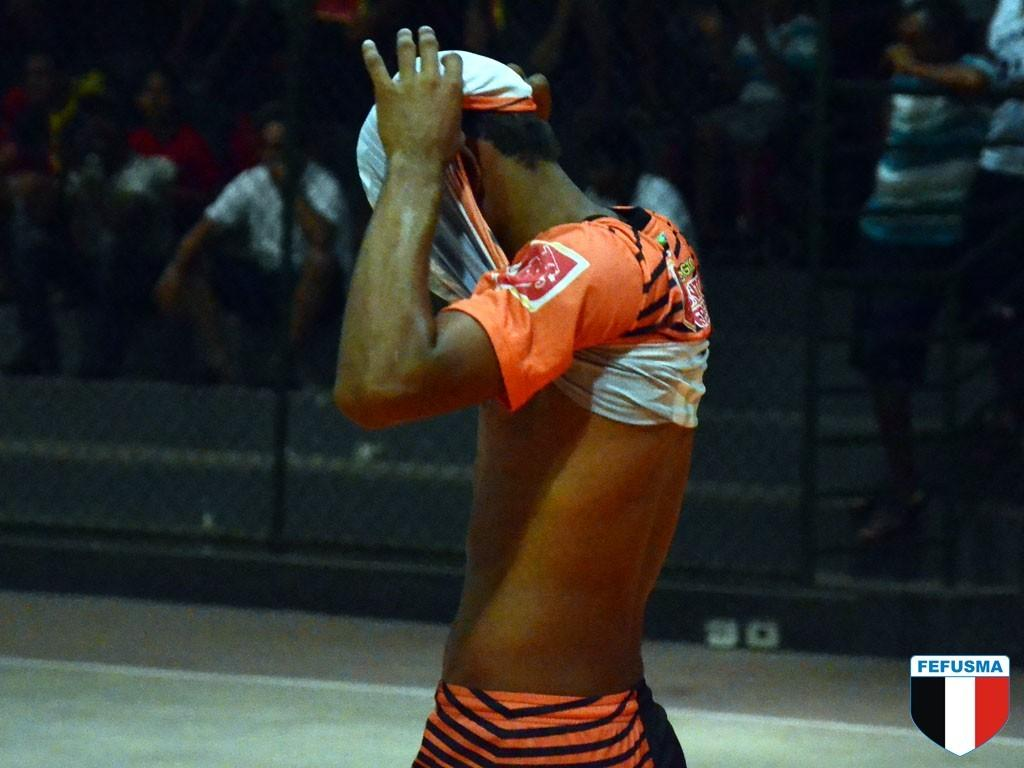<image>
Provide a brief description of the given image. A man lifts his shirt above his head at a FEFUSMA event. 